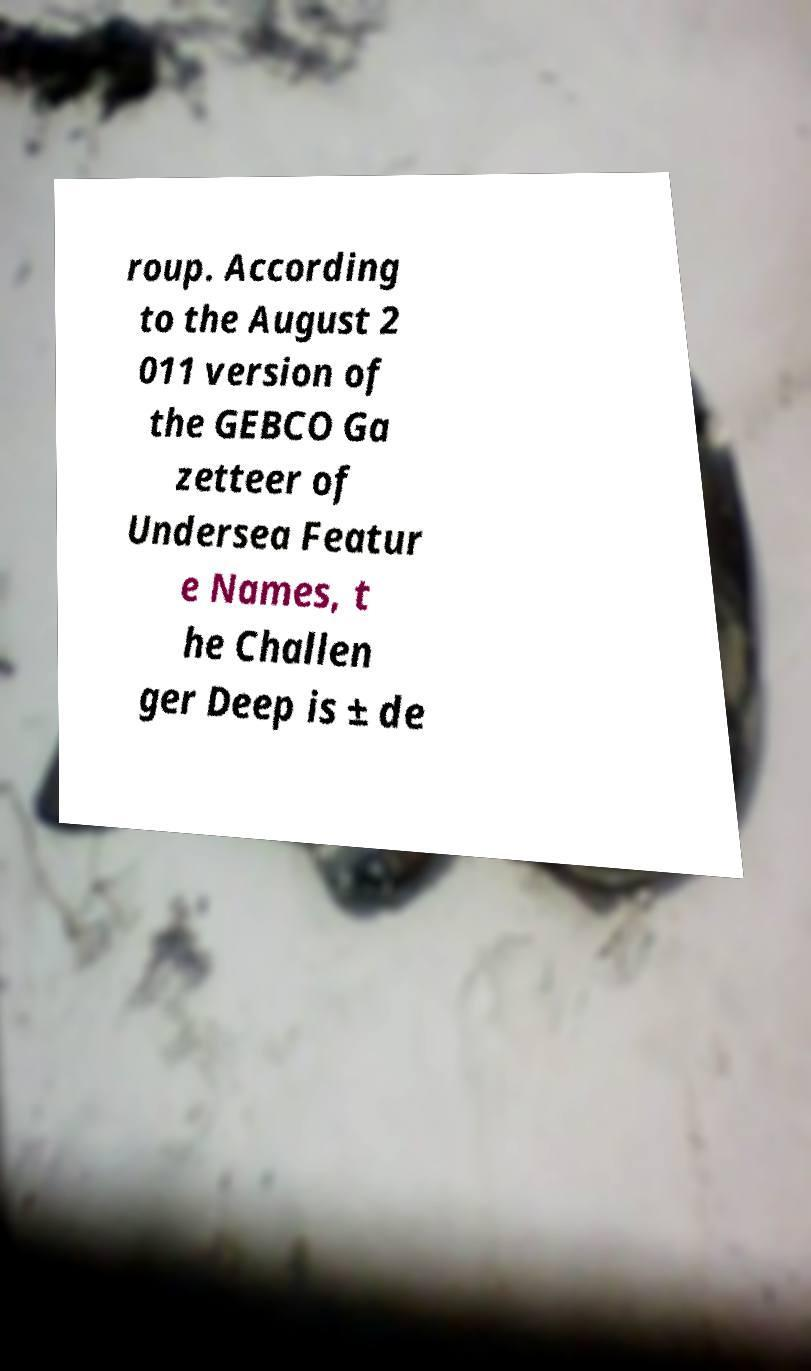Can you read and provide the text displayed in the image?This photo seems to have some interesting text. Can you extract and type it out for me? roup. According to the August 2 011 version of the GEBCO Ga zetteer of Undersea Featur e Names, t he Challen ger Deep is ± de 